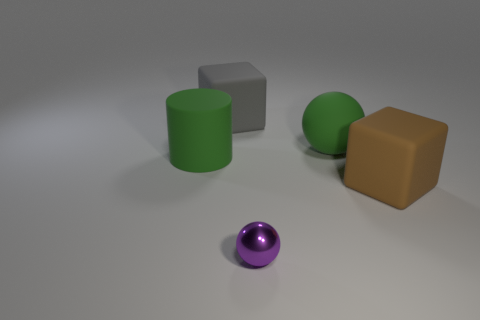How many purple shiny things are the same shape as the gray object?
Your answer should be very brief. 0. Are the big gray thing and the brown cube made of the same material?
Offer a terse response. Yes. What is the shape of the thing in front of the cube in front of the green cylinder?
Your answer should be very brief. Sphere. There is a big block to the left of the large brown object; what number of big brown blocks are to the left of it?
Your answer should be very brief. 0. What material is the big object that is both right of the gray thing and in front of the big sphere?
Ensure brevity in your answer.  Rubber. There is a green thing that is the same size as the green sphere; what is its shape?
Your answer should be compact. Cylinder. What is the color of the big object that is left of the large matte cube that is left of the large cube that is on the right side of the large sphere?
Your response must be concise. Green. What number of things are green things that are in front of the large sphere or tiny green matte objects?
Offer a terse response. 1. There is a brown cube that is the same size as the matte sphere; what material is it?
Your answer should be compact. Rubber. There is a block that is to the left of the rubber block that is on the right side of the big rubber block to the left of the tiny sphere; what is its material?
Give a very brief answer. Rubber. 